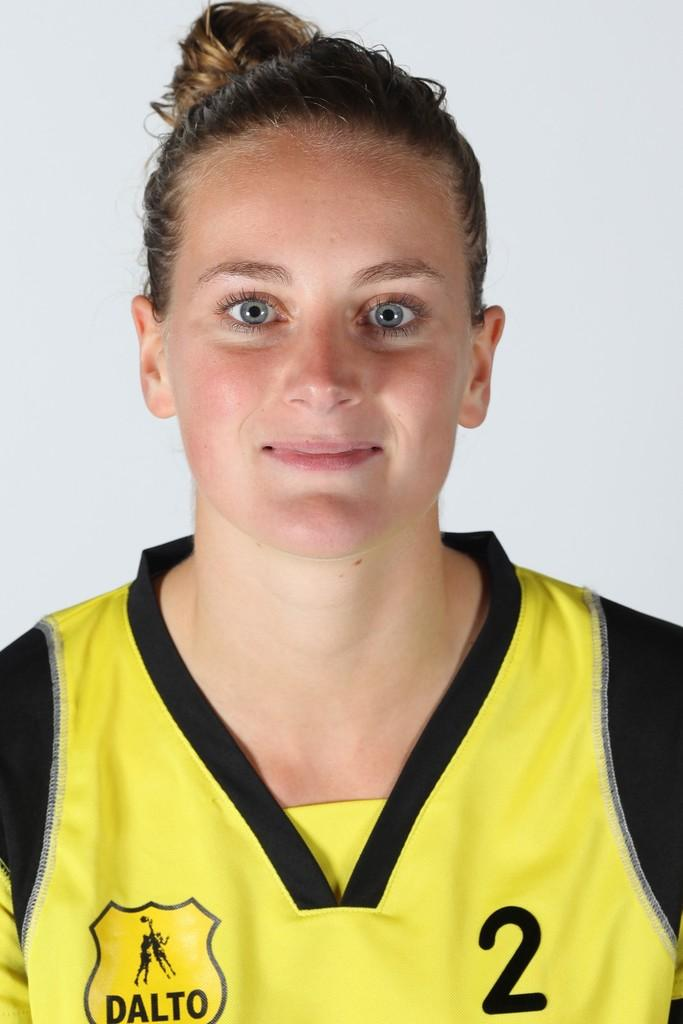<image>
Relay a brief, clear account of the picture shown. A girl wearing a yellow and black shirt with Dalto and the number two on the shirt. 